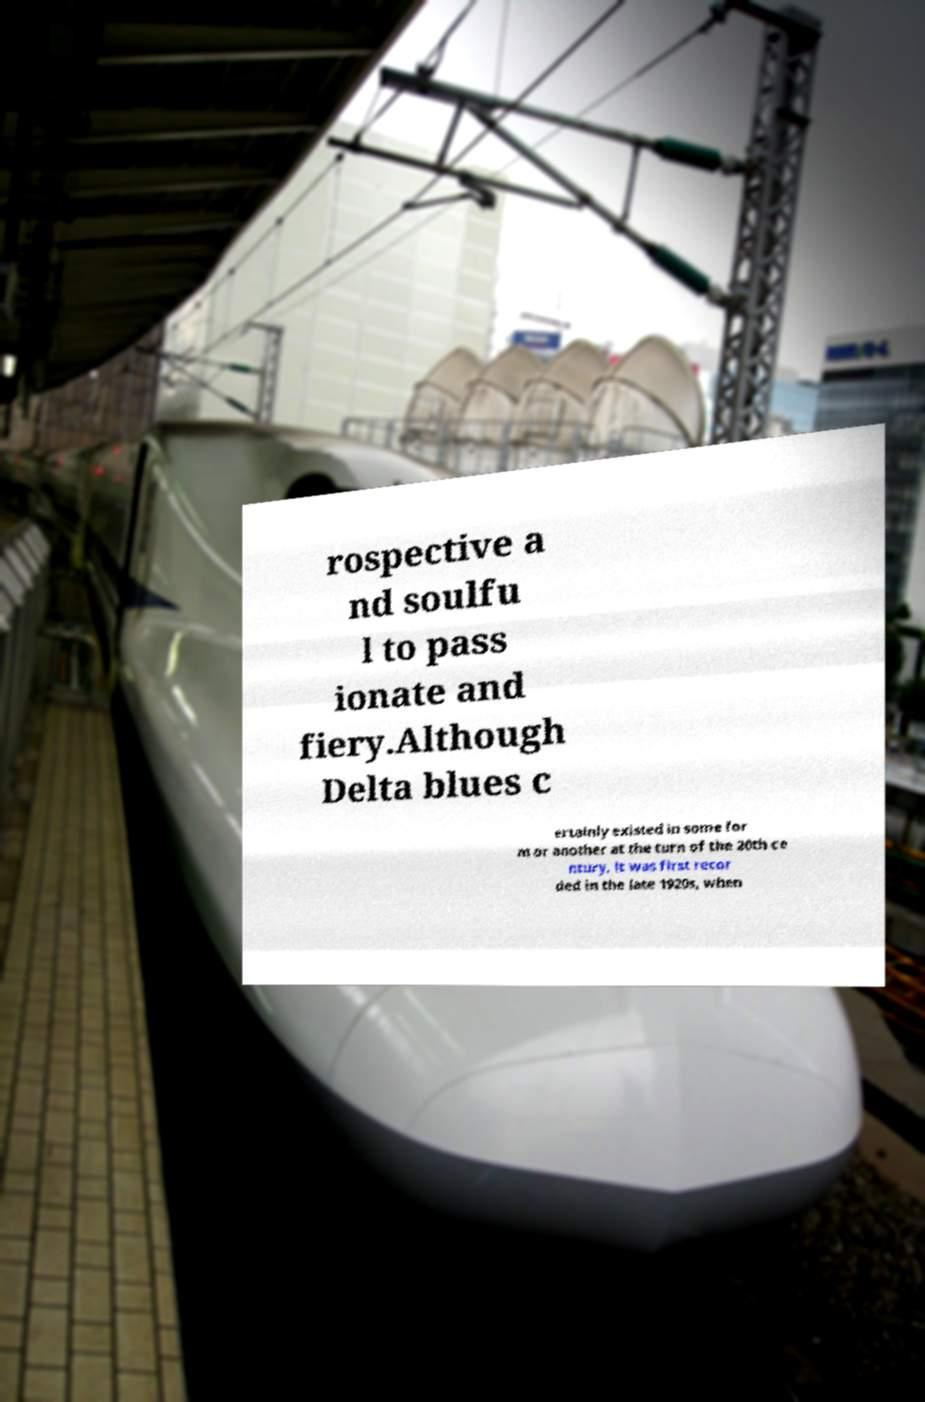Could you assist in decoding the text presented in this image and type it out clearly? rospective a nd soulfu l to pass ionate and fiery.Although Delta blues c ertainly existed in some for m or another at the turn of the 20th ce ntury, it was first recor ded in the late 1920s, when 